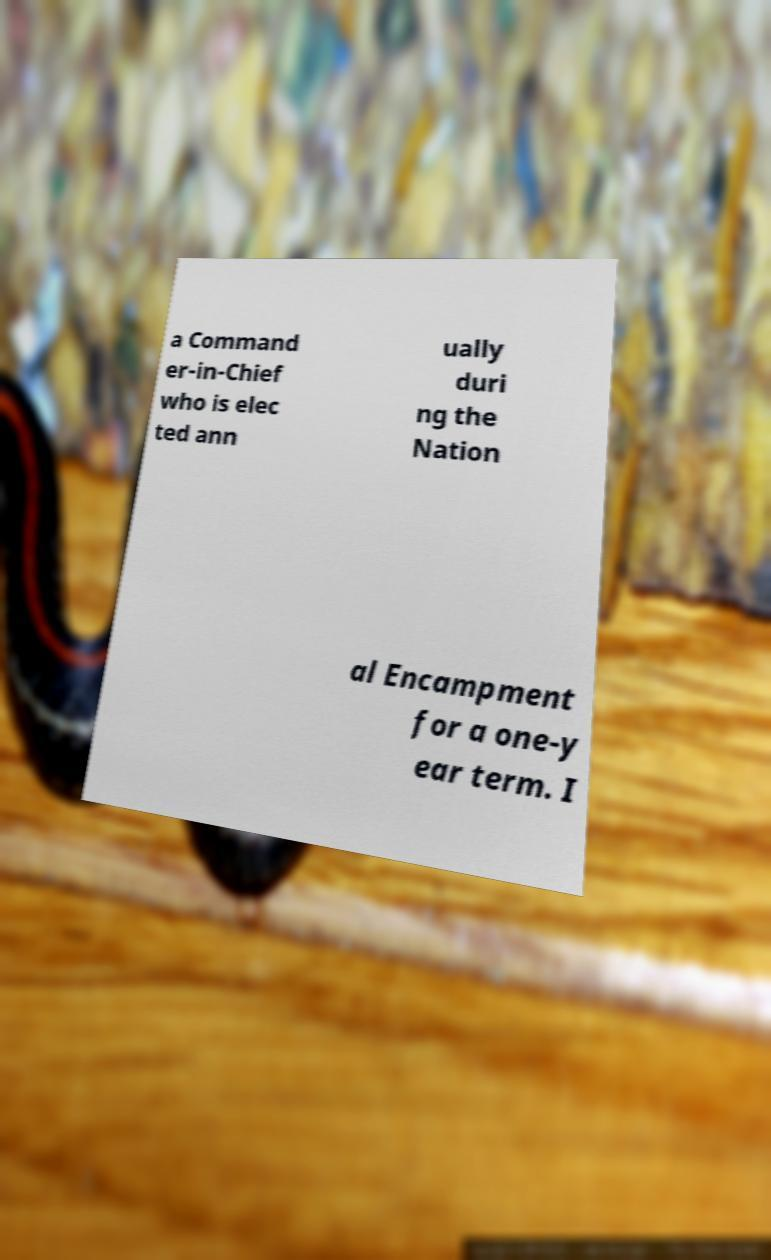For documentation purposes, I need the text within this image transcribed. Could you provide that? a Command er-in-Chief who is elec ted ann ually duri ng the Nation al Encampment for a one-y ear term. I 